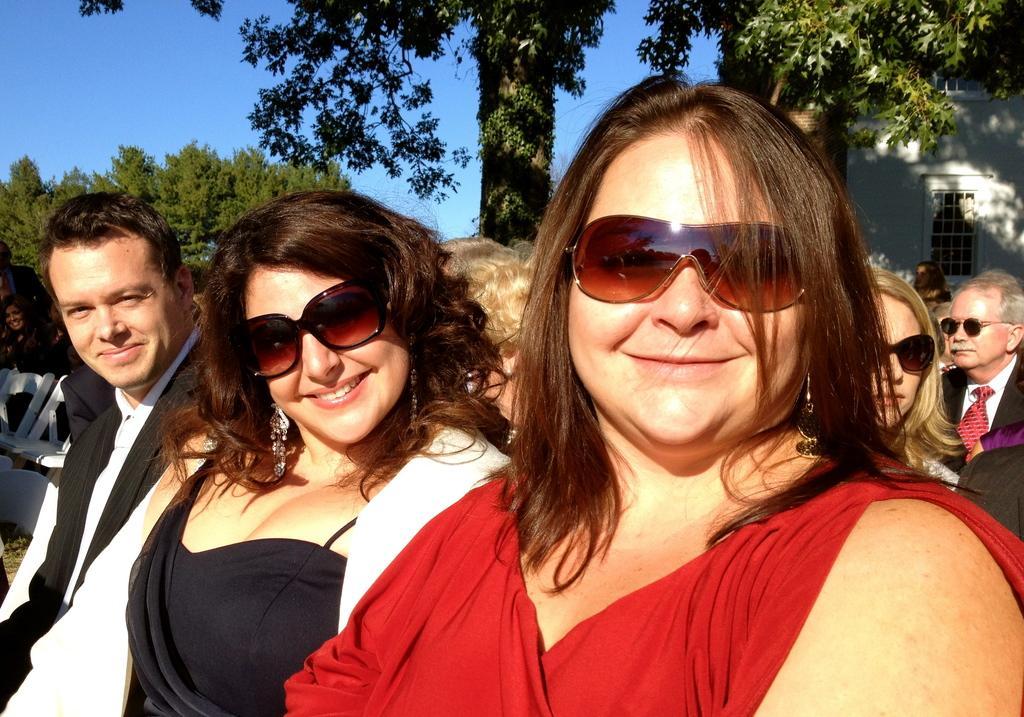How would you summarize this image in a sentence or two? In this image I can see few persons sitting. In front the person is wearing red color dress, background I can see a building in white color, trees in green color and the sky is in blue color. 